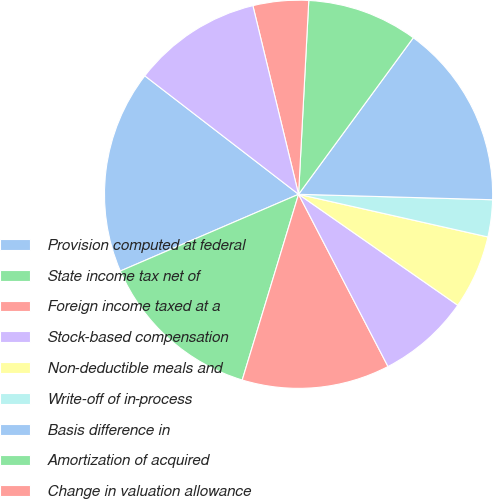<chart> <loc_0><loc_0><loc_500><loc_500><pie_chart><fcel>Provision computed at federal<fcel>State income tax net of<fcel>Foreign income taxed at a<fcel>Stock-based compensation<fcel>Non-deductible meals and<fcel>Write-off of in-process<fcel>Basis difference in<fcel>Amortization of acquired<fcel>Change in valuation allowance<fcel>Research and development tax<nl><fcel>16.92%<fcel>13.84%<fcel>12.31%<fcel>7.69%<fcel>6.16%<fcel>3.08%<fcel>15.38%<fcel>9.23%<fcel>4.62%<fcel>10.77%<nl></chart> 